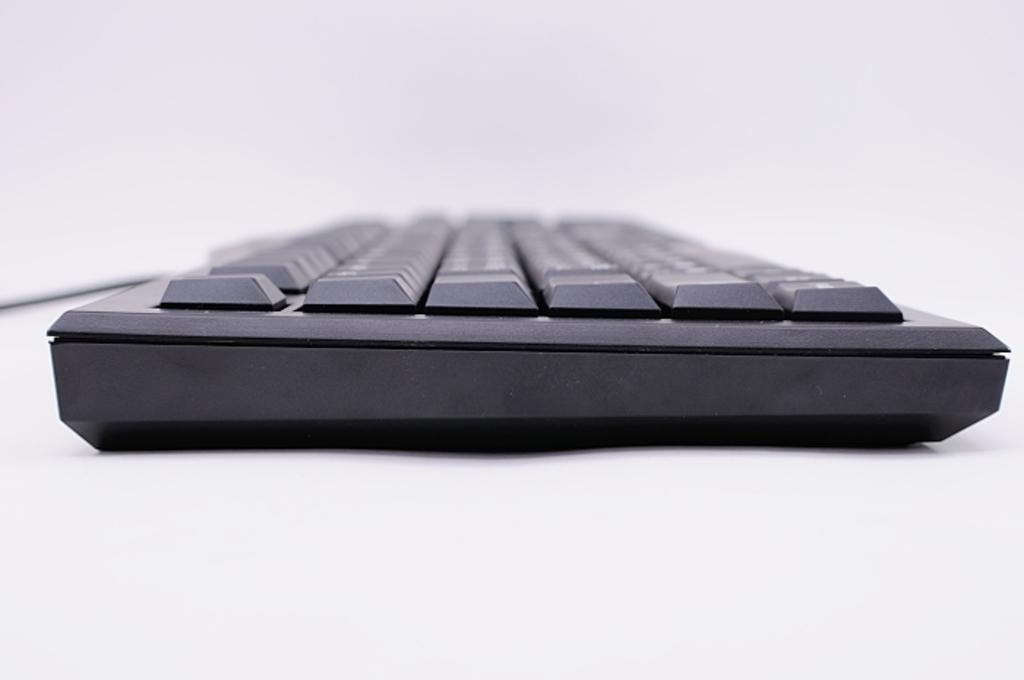What is the main object in the image? There is a keyboard in the image. What color is the keyboard? The keyboard is black in color. Where is the keyboard located? The keyboard is present on a table. How does the earthquake affect the connection between the keyboard and the table in the image? There is no earthquake present in the image, so its effect on the connection between the keyboard and the table cannot be determined. 